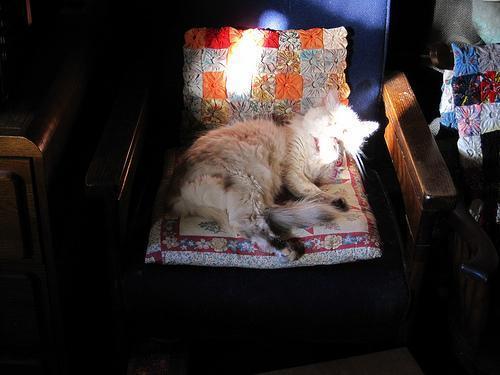How many animals are there?
Give a very brief answer. 1. 